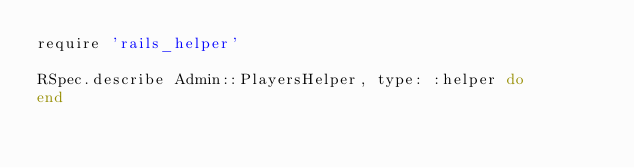<code> <loc_0><loc_0><loc_500><loc_500><_Ruby_>require 'rails_helper'

RSpec.describe Admin::PlayersHelper, type: :helper do
end
</code> 